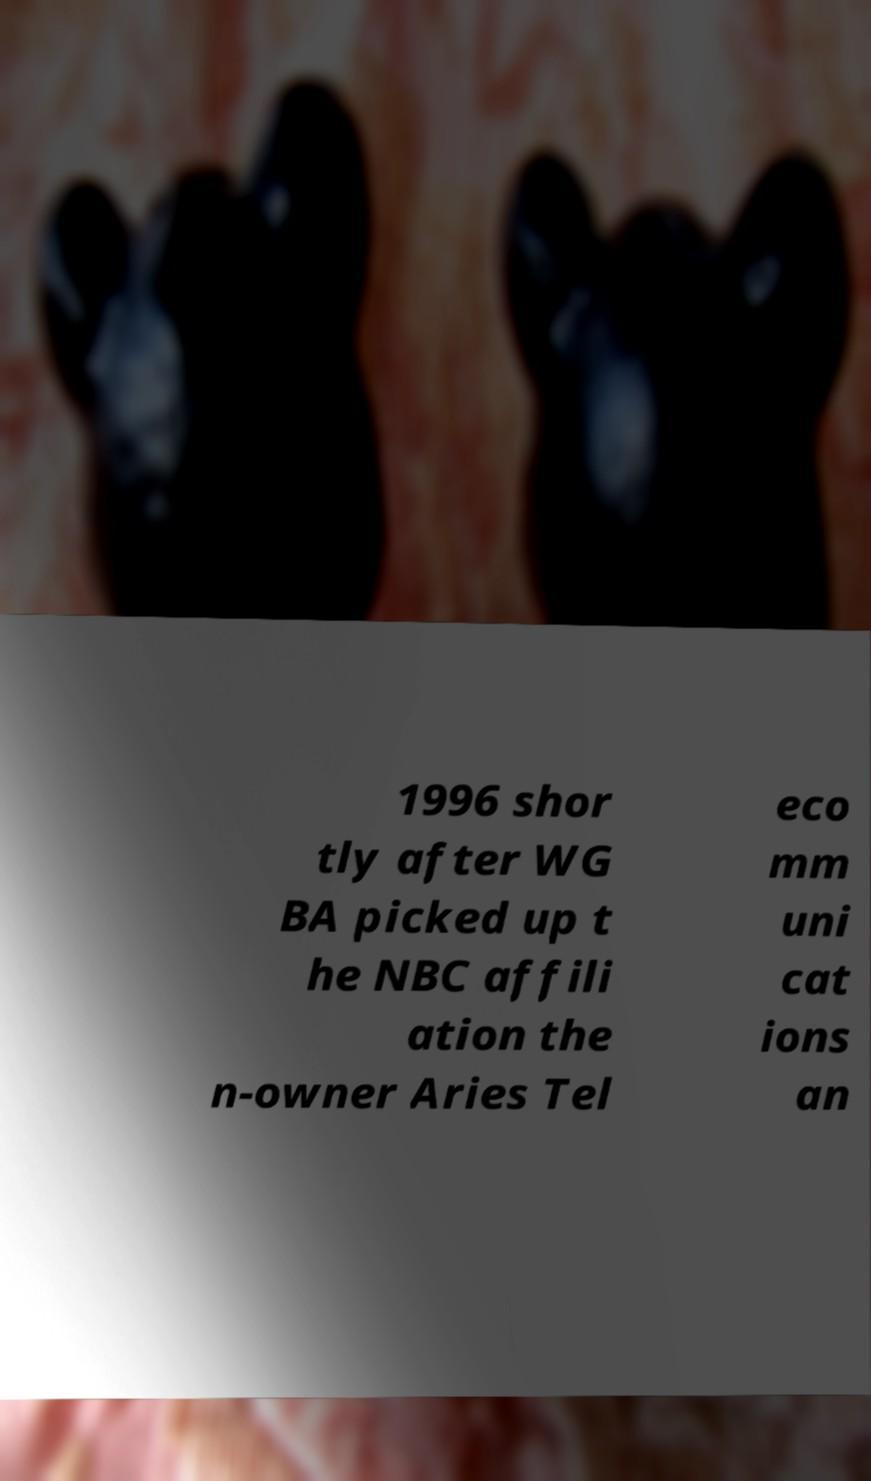Please read and relay the text visible in this image. What does it say? 1996 shor tly after WG BA picked up t he NBC affili ation the n-owner Aries Tel eco mm uni cat ions an 